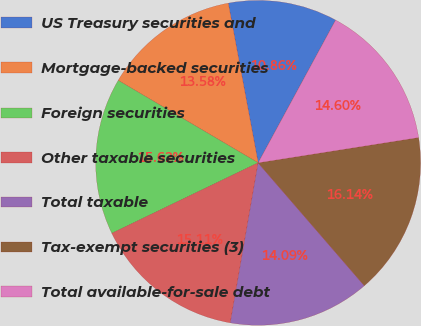Convert chart to OTSL. <chart><loc_0><loc_0><loc_500><loc_500><pie_chart><fcel>US Treasury securities and<fcel>Mortgage-backed securities<fcel>Foreign securities<fcel>Other taxable securities<fcel>Total taxable<fcel>Tax-exempt securities (3)<fcel>Total available-for-sale debt<nl><fcel>10.86%<fcel>13.58%<fcel>15.62%<fcel>15.11%<fcel>14.09%<fcel>16.14%<fcel>14.6%<nl></chart> 